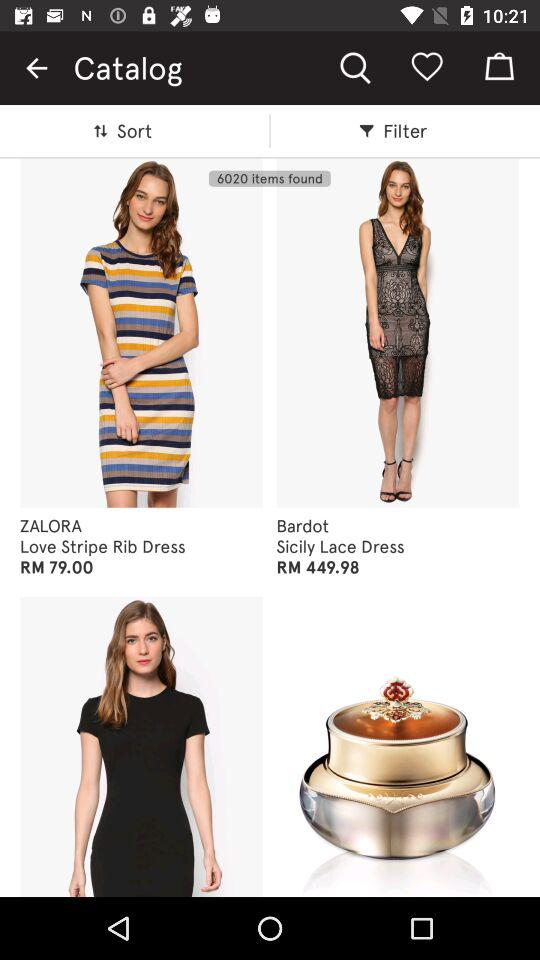What is the name of the brand of the "Love Stripe Rib Dress"? The name of the brand is "ZALORA". 